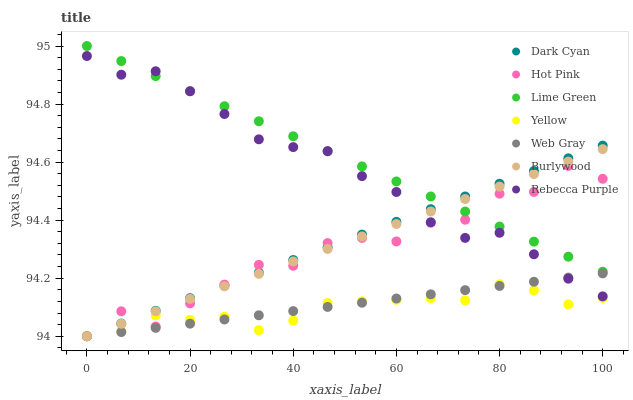Does Yellow have the minimum area under the curve?
Answer yes or no. Yes. Does Lime Green have the maximum area under the curve?
Answer yes or no. Yes. Does Burlywood have the minimum area under the curve?
Answer yes or no. No. Does Burlywood have the maximum area under the curve?
Answer yes or no. No. Is Dark Cyan the smoothest?
Answer yes or no. Yes. Is Hot Pink the roughest?
Answer yes or no. Yes. Is Burlywood the smoothest?
Answer yes or no. No. Is Burlywood the roughest?
Answer yes or no. No. Does Web Gray have the lowest value?
Answer yes or no. Yes. Does Rebecca Purple have the lowest value?
Answer yes or no. No. Does Lime Green have the highest value?
Answer yes or no. Yes. Does Burlywood have the highest value?
Answer yes or no. No. Is Yellow less than Lime Green?
Answer yes or no. Yes. Is Lime Green greater than Web Gray?
Answer yes or no. Yes. Does Dark Cyan intersect Web Gray?
Answer yes or no. Yes. Is Dark Cyan less than Web Gray?
Answer yes or no. No. Is Dark Cyan greater than Web Gray?
Answer yes or no. No. Does Yellow intersect Lime Green?
Answer yes or no. No. 